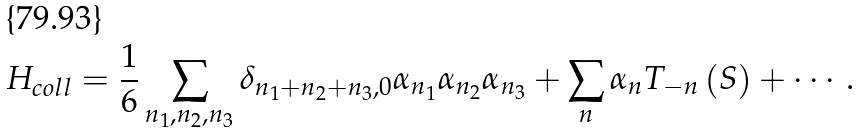<formula> <loc_0><loc_0><loc_500><loc_500>H _ { c o l l } = \frac { 1 } { 6 } \sum _ { n _ { 1 } , n _ { 2 } , n _ { 3 } } \delta _ { n _ { 1 } + n _ { 2 } + n _ { 3 } , 0 } \alpha _ { n _ { 1 } } \alpha _ { n _ { 2 } } \alpha _ { n _ { 3 } } + \sum _ { n } \alpha _ { n } T _ { - n } \left ( S \right ) + \cdots .</formula> 